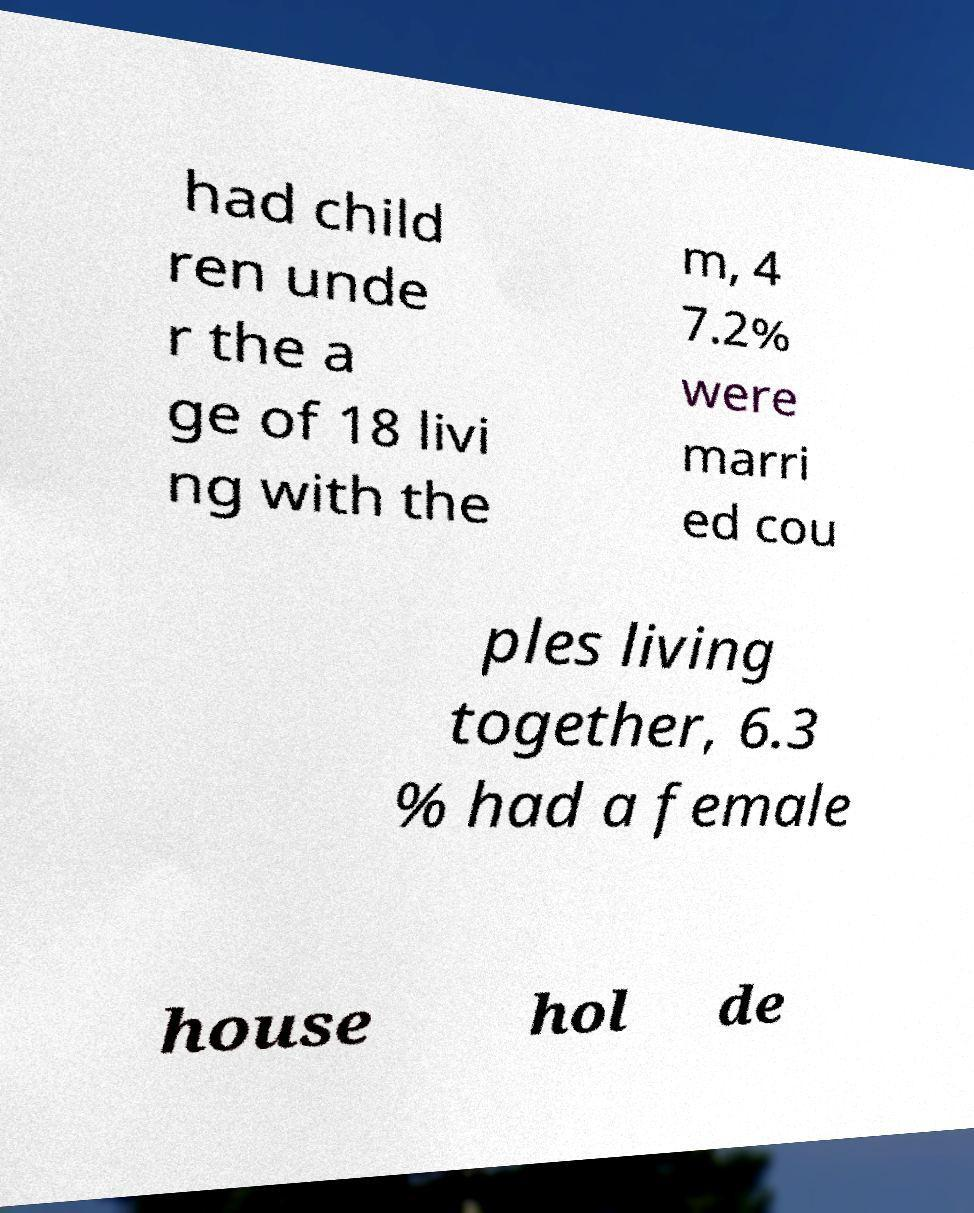Can you accurately transcribe the text from the provided image for me? had child ren unde r the a ge of 18 livi ng with the m, 4 7.2% were marri ed cou ples living together, 6.3 % had a female house hol de 